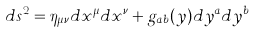<formula> <loc_0><loc_0><loc_500><loc_500>d s ^ { 2 } = \eta _ { \mu \nu } d x ^ { \mu } d x ^ { \nu } + g _ { a b } ( y ) d y ^ { a } d y ^ { b }</formula> 